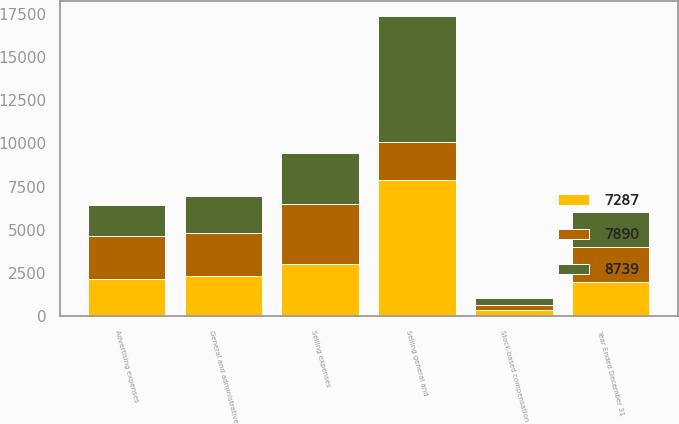Convert chart to OTSL. <chart><loc_0><loc_0><loc_500><loc_500><stacked_bar_chart><ecel><fcel>Year Ended December 31<fcel>Selling expenses<fcel>Advertising expenses<fcel>General and administrative<fcel>Stock-based compensation<fcel>Selling general and<nl><fcel>7890<fcel>2005<fcel>3453<fcel>2475<fcel>2487<fcel>324<fcel>2165<nl><fcel>7287<fcel>2004<fcel>3031<fcel>2165<fcel>2349<fcel>345<fcel>7890<nl><fcel>8739<fcel>2003<fcel>2937<fcel>1822<fcel>2121<fcel>407<fcel>7287<nl></chart> 